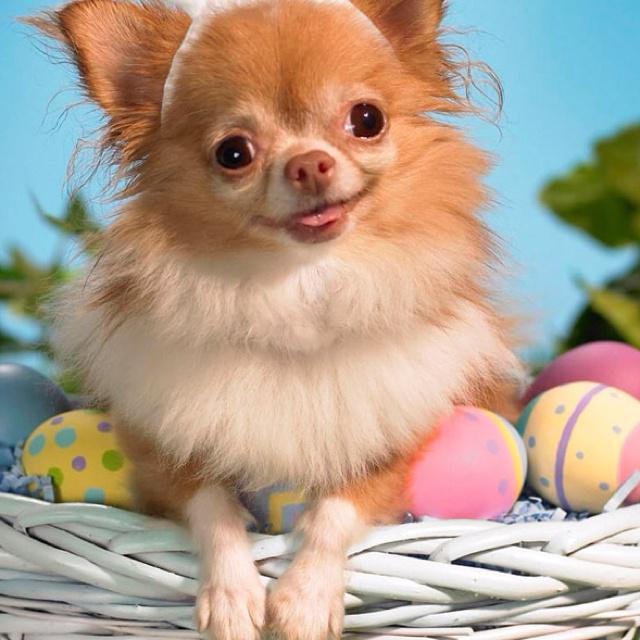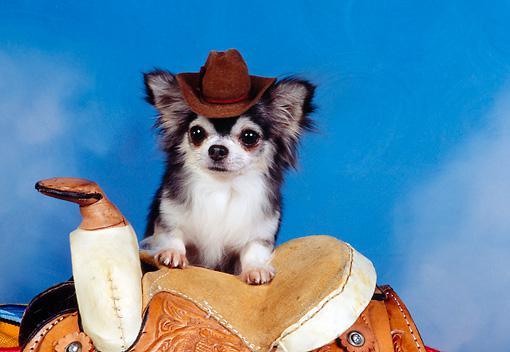The first image is the image on the left, the second image is the image on the right. For the images shown, is this caption "The dog dressed in costume in the right hand image is photographed against a blue background." true? Answer yes or no. Yes. The first image is the image on the left, the second image is the image on the right. Given the left and right images, does the statement "The right image contains a dog wearing a small hat." hold true? Answer yes or no. Yes. 